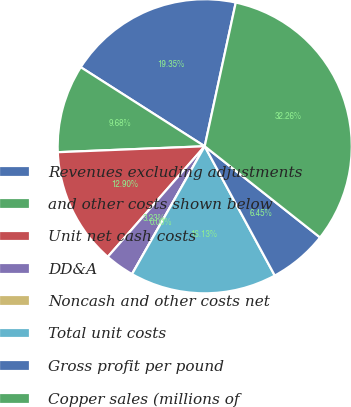Convert chart. <chart><loc_0><loc_0><loc_500><loc_500><pie_chart><fcel>Revenues excluding adjustments<fcel>and other costs shown below<fcel>Unit net cash costs<fcel>DD&A<fcel>Noncash and other costs net<fcel>Total unit costs<fcel>Gross profit per pound<fcel>Copper sales (millions of<nl><fcel>19.35%<fcel>9.68%<fcel>12.9%<fcel>3.23%<fcel>0.0%<fcel>16.13%<fcel>6.45%<fcel>32.26%<nl></chart> 